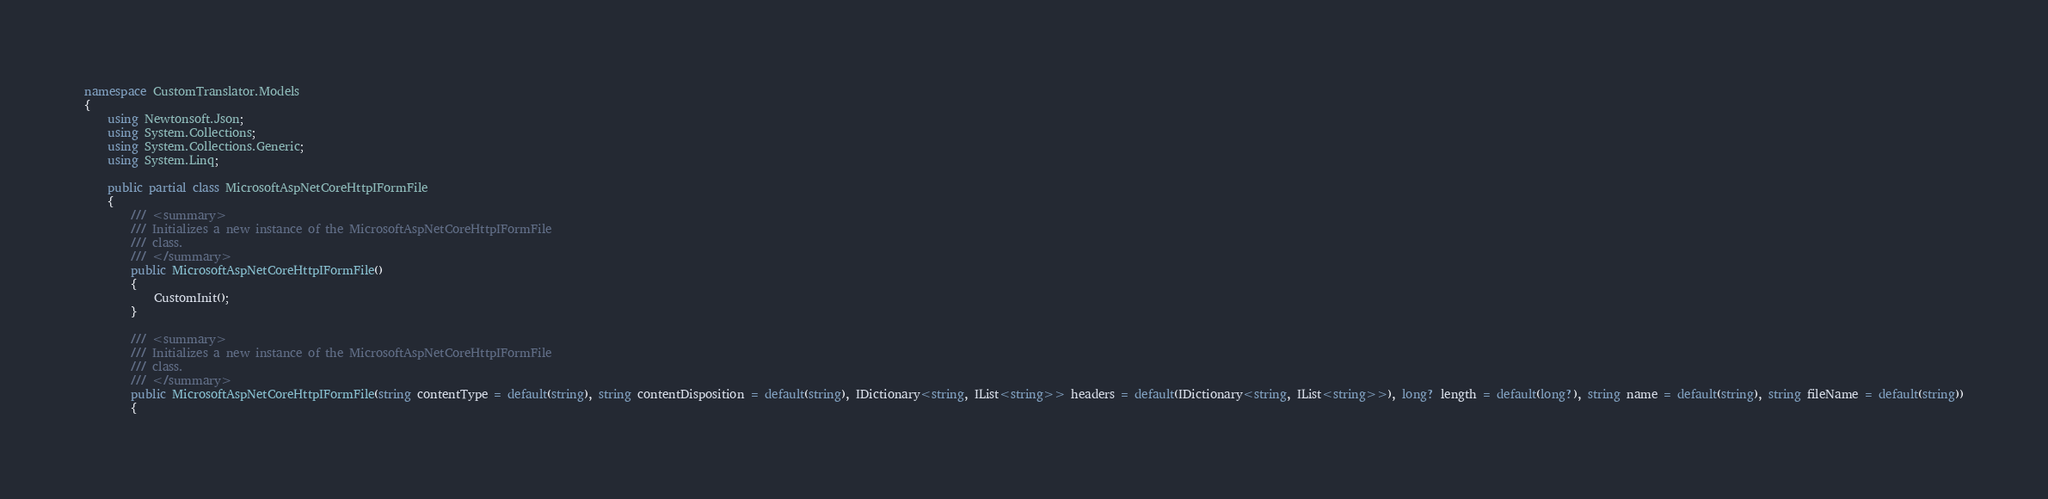Convert code to text. <code><loc_0><loc_0><loc_500><loc_500><_C#_>
namespace CustomTranslator.Models
{
    using Newtonsoft.Json;
    using System.Collections;
    using System.Collections.Generic;
    using System.Linq;

    public partial class MicrosoftAspNetCoreHttpIFormFile
    {
        /// <summary>
        /// Initializes a new instance of the MicrosoftAspNetCoreHttpIFormFile
        /// class.
        /// </summary>
        public MicrosoftAspNetCoreHttpIFormFile()
        {
            CustomInit();
        }

        /// <summary>
        /// Initializes a new instance of the MicrosoftAspNetCoreHttpIFormFile
        /// class.
        /// </summary>
        public MicrosoftAspNetCoreHttpIFormFile(string contentType = default(string), string contentDisposition = default(string), IDictionary<string, IList<string>> headers = default(IDictionary<string, IList<string>>), long? length = default(long?), string name = default(string), string fileName = default(string))
        {</code> 